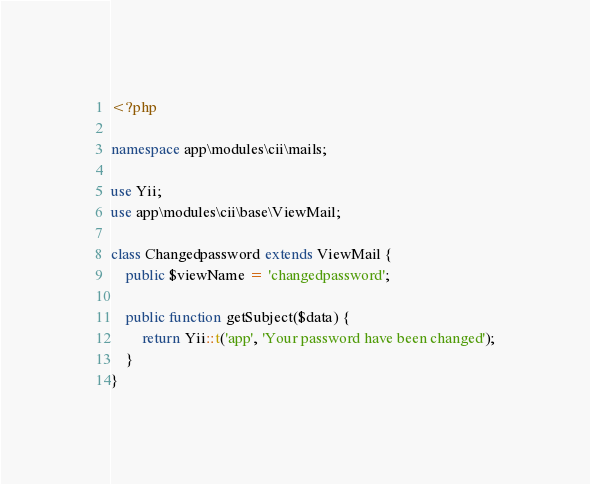<code> <loc_0><loc_0><loc_500><loc_500><_PHP_><?php

namespace app\modules\cii\mails;

use Yii;
use app\modules\cii\base\ViewMail;

class Changedpassword extends ViewMail {
    public $viewName = 'changedpassword';
    
    public function getSubject($data) {
        return Yii::t('app', 'Your password have been changed');
    }
}</code> 